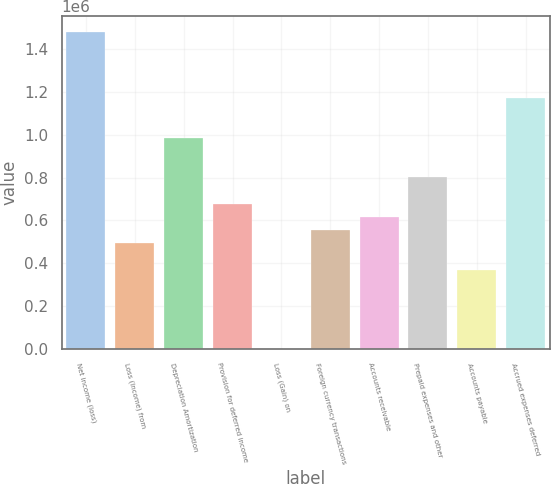Convert chart to OTSL. <chart><loc_0><loc_0><loc_500><loc_500><bar_chart><fcel>Net income (loss)<fcel>Loss (Income) from<fcel>Depreciation Amortization<fcel>Provision for deferred income<fcel>Loss (Gain) on<fcel>Foreign currency transactions<fcel>Accounts receivable<fcel>Prepaid expenses and other<fcel>Accounts payable<fcel>Accrued expenses deferred<nl><fcel>1.48035e+06<fcel>493562<fcel>986957<fcel>678585<fcel>168<fcel>555237<fcel>616911<fcel>801934<fcel>370214<fcel>1.17198e+06<nl></chart> 